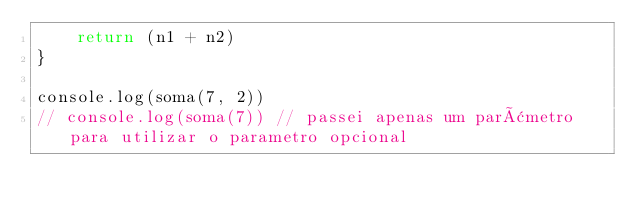Convert code to text. <code><loc_0><loc_0><loc_500><loc_500><_JavaScript_>    return (n1 + n2)
}

console.log(soma(7, 2))
// console.log(soma(7)) // passei apenas um parâmetro para utilizar o parametro opcional</code> 